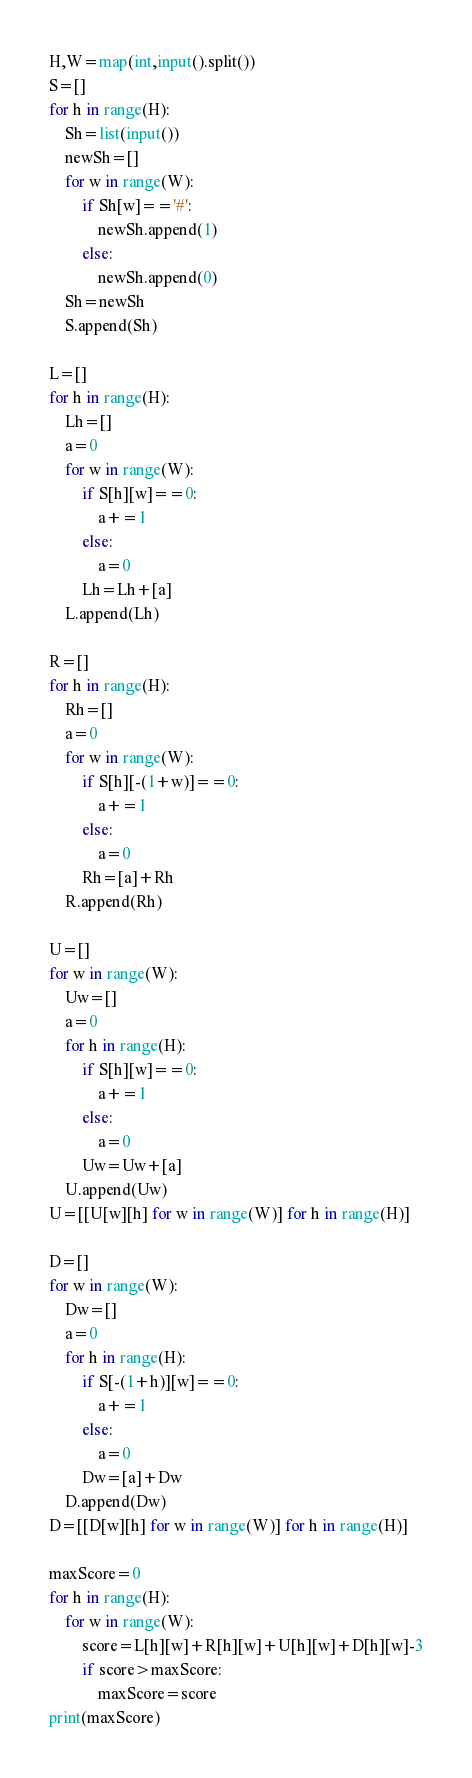Convert code to text. <code><loc_0><loc_0><loc_500><loc_500><_Python_>H,W=map(int,input().split())
S=[]
for h in range(H):
    Sh=list(input())
    newSh=[]
    for w in range(W):
        if Sh[w]=='#':
            newSh.append(1)
        else:
            newSh.append(0)
    Sh=newSh
    S.append(Sh)
    
L=[]
for h in range(H):
    Lh=[]
    a=0
    for w in range(W):
        if S[h][w]==0:
            a+=1
        else:
            a=0
        Lh=Lh+[a]
    L.append(Lh)

R=[]
for h in range(H):
    Rh=[]
    a=0
    for w in range(W):
        if S[h][-(1+w)]==0:
            a+=1
        else:
            a=0
        Rh=[a]+Rh
    R.append(Rh)

U=[]
for w in range(W):
    Uw=[]
    a=0
    for h in range(H):
        if S[h][w]==0:
            a+=1
        else:
            a=0
        Uw=Uw+[a]
    U.append(Uw)
U=[[U[w][h] for w in range(W)] for h in range(H)]
    
D=[]
for w in range(W):
    Dw=[]
    a=0
    for h in range(H):
        if S[-(1+h)][w]==0:
            a+=1
        else:
            a=0
        Dw=[a]+Dw
    D.append(Dw)
D=[[D[w][h] for w in range(W)] for h in range(H)]

maxScore=0
for h in range(H):
    for w in range(W):
        score=L[h][w]+R[h][w]+U[h][w]+D[h][w]-3
        if score>maxScore:
            maxScore=score
print(maxScore)</code> 